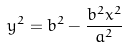<formula> <loc_0><loc_0><loc_500><loc_500>y ^ { 2 } = b ^ { 2 } - \frac { b ^ { 2 } x ^ { 2 } } { a ^ { 2 } }</formula> 